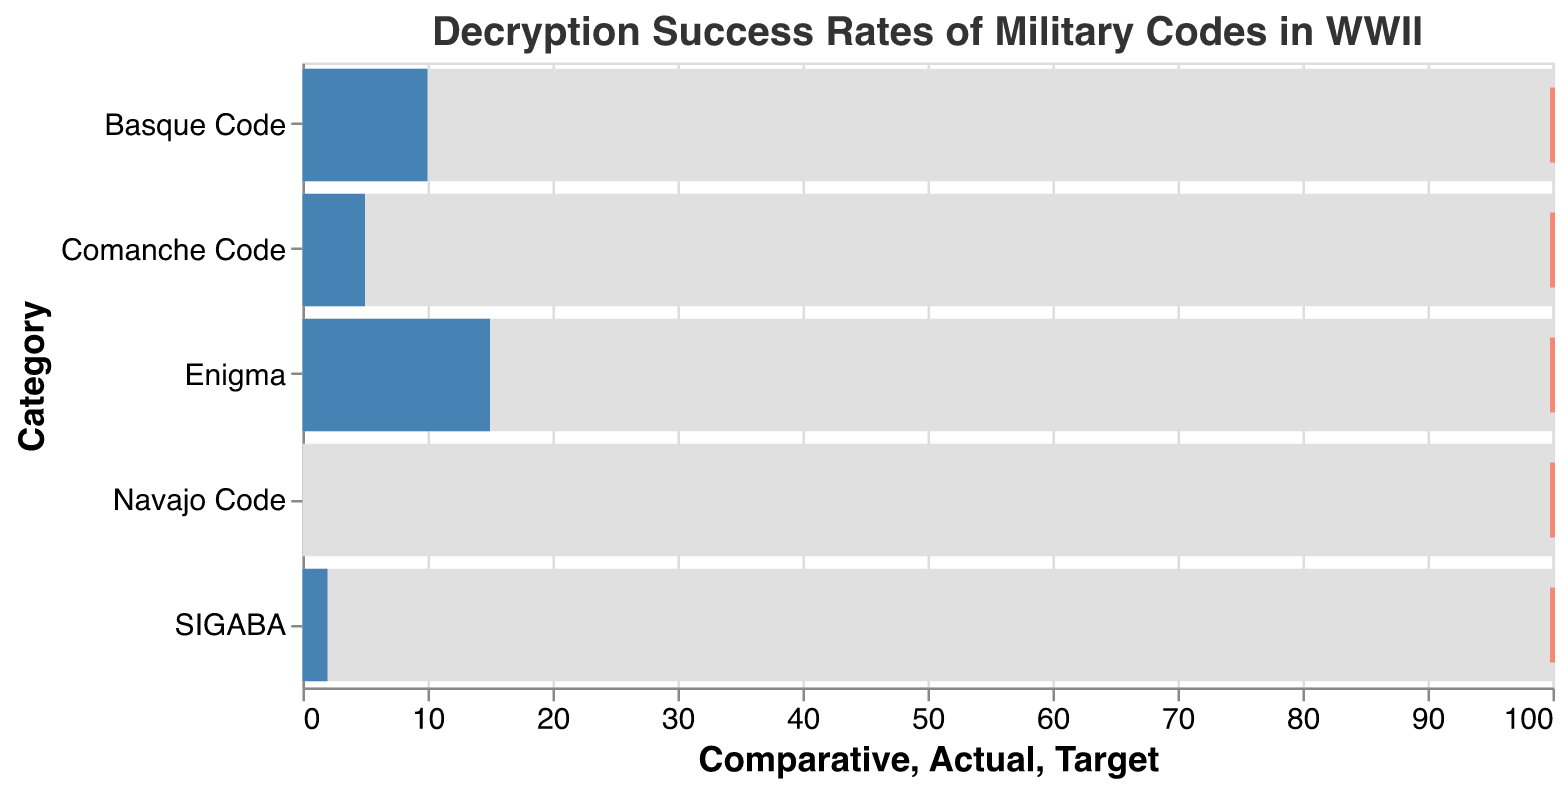What is the topic of the plot? The title of the plot states "Decryption Success Rates of Military Codes in WWII," indicating the subject of the visualization.
Answer: Decryption Success Rates of Military Codes in WWII Which code had the lowest decryption success rate? By looking at the length of the blue bars representing the decryption success rates, the Navajo Code has an Actual value of 0, which is the lowest.
Answer: Navajo Code What is the maximum comparative decryption rate for each code category? All the comparative decryption rates shown by the gray bars are equal and reach the maximum value of 100 for each code category.
Answer: 100 How much higher is the decryption success rate of SIGABA compared to the Navajo Code? The Navajo Code has a decryption success rate of 0, while SIGABA has a rate of 2. To find the difference, subtract 0 from 2.
Answer: 2 What percentage of the target rate did the Enigma code achieve? The target rate is 100 for each code. Enigma has an actual rate of 15. To find the percentage, (15/100) * 100 = 15%.
Answer: 15% How do the decryption success rates of the Comanche Code and the Basque Code compare? The Comanche Code has a success rate of 5, while the Basque Code has a rate of 10. The Basque Code's rate is 5 points higher than the Comanche Code's rate.
Answer: Basque Code is 5 points higher Which code had the highest decryption success rate? The length of the blue bars shows that the Enigma code had the highest decryption success rate at 15.
Answer: Enigma How does the actual success rate of the Navajo Code compare with its target rate? The target rate for the Navajo Code is 100, and its actual success rate is 0. The actual rate is significantly lower and falls short of the target by 100 points.
Answer: 100 points short What was the success rate of the Basque Code relative to SIGABA? The Basque Code has a higher success rate at 10, compared to SIGABA's rate of 2. To find the relative difference, subtract 2 from 10, which equals 8.
Answer: 8 points higher If the target success rate is 100 for all codes, which code came closest to its target? The blue bars represent actual rates and are compared to the red tick marks representing the target rate of 100. The one closest to 100 is Enigma, though it still falls short considerably.
Answer: Enigma 